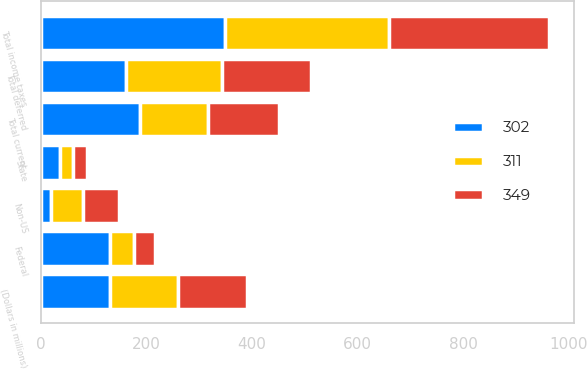Convert chart to OTSL. <chart><loc_0><loc_0><loc_500><loc_500><stacked_bar_chart><ecel><fcel>(Dollars in millions)<fcel>Federal<fcel>State<fcel>Non-US<fcel>Total current<fcel>Total deferred<fcel>Total income taxes<nl><fcel>349<fcel>130<fcel>39<fcel>28<fcel>67<fcel>134<fcel>168<fcel>302<nl><fcel>311<fcel>130<fcel>47<fcel>23<fcel>60<fcel>130<fcel>181<fcel>311<nl><fcel>302<fcel>130<fcel>130<fcel>37<fcel>20<fcel>187<fcel>162<fcel>349<nl></chart> 